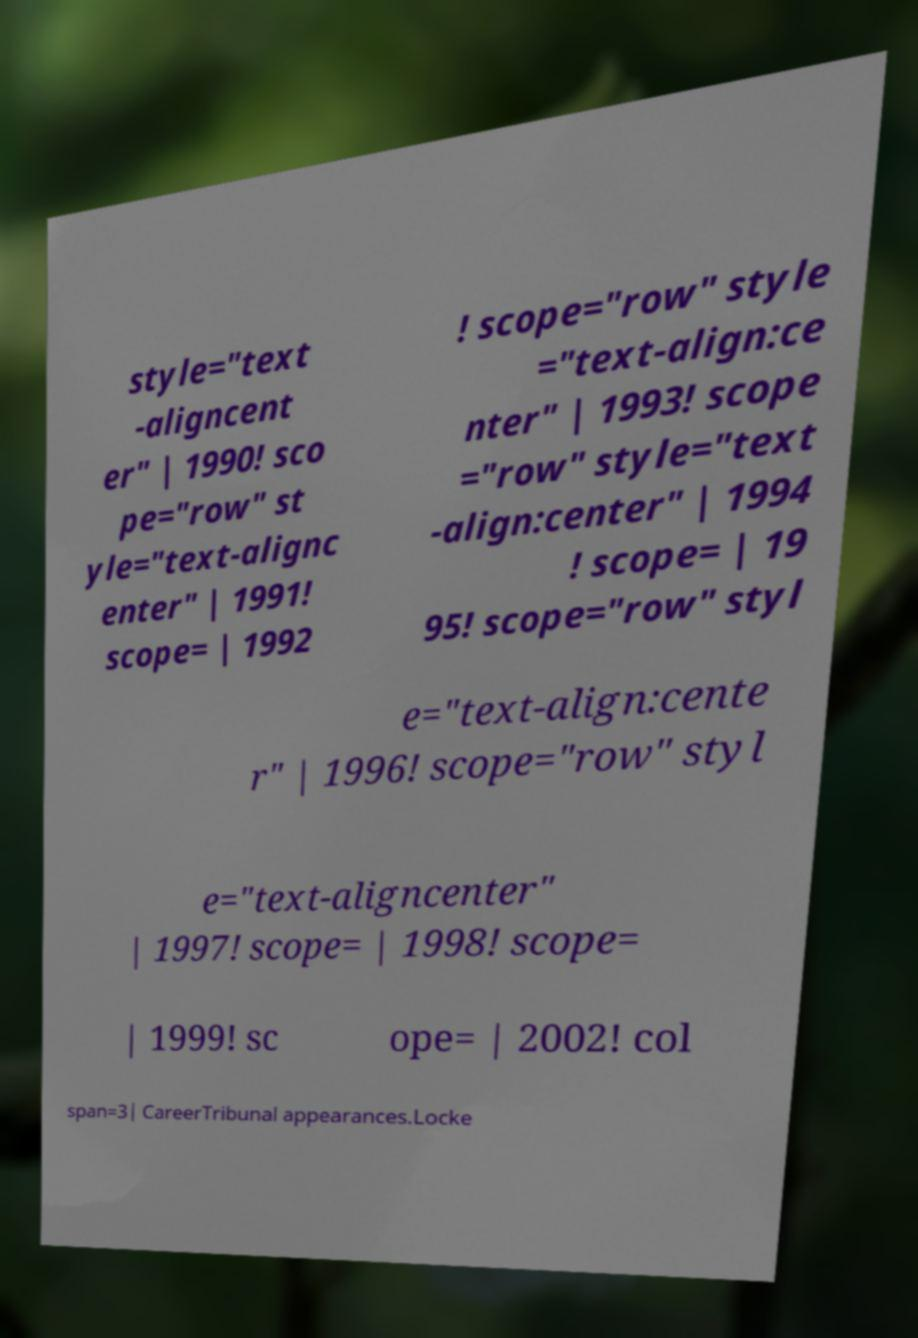I need the written content from this picture converted into text. Can you do that? style="text -aligncent er" | 1990! sco pe="row" st yle="text-alignc enter" | 1991! scope= | 1992 ! scope="row" style ="text-align:ce nter" | 1993! scope ="row" style="text -align:center" | 1994 ! scope= | 19 95! scope="row" styl e="text-align:cente r" | 1996! scope="row" styl e="text-aligncenter" | 1997! scope= | 1998! scope= | 1999! sc ope= | 2002! col span=3| CareerTribunal appearances.Locke 